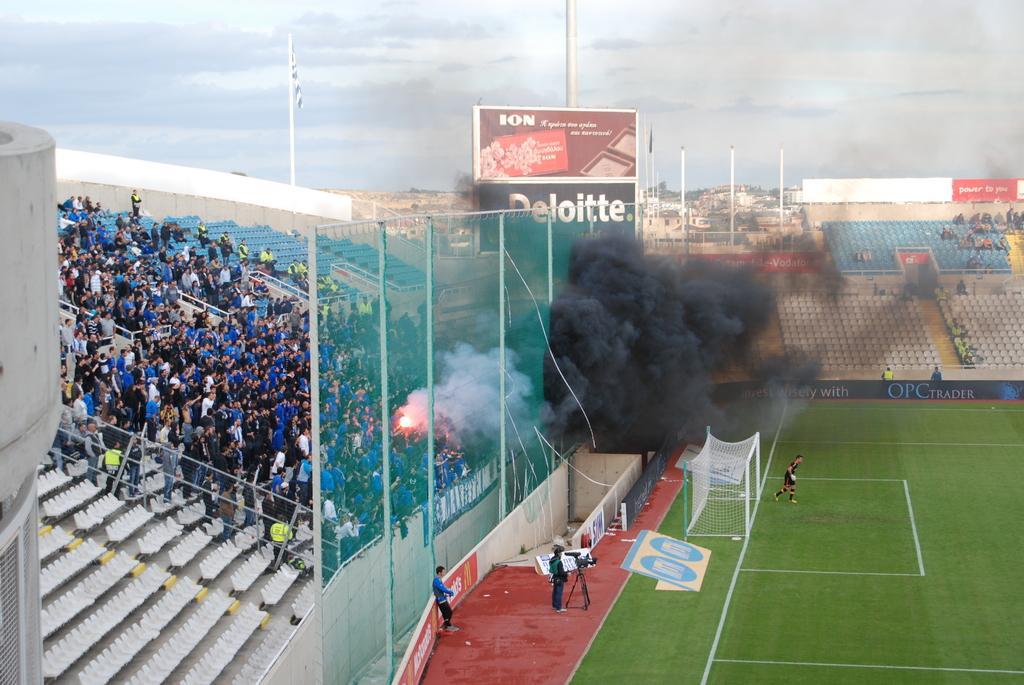Please provide a concise description of this image. This picture might be taken in a stadium, in this picture on the left side there are some people who are standing and also there are some chairs and at the bottom there is ground and some players and one person is holding a camera and in the center there is a fog and light in the background there are some houses poles chairs and some people are sitting on the top of the image there is sky. 